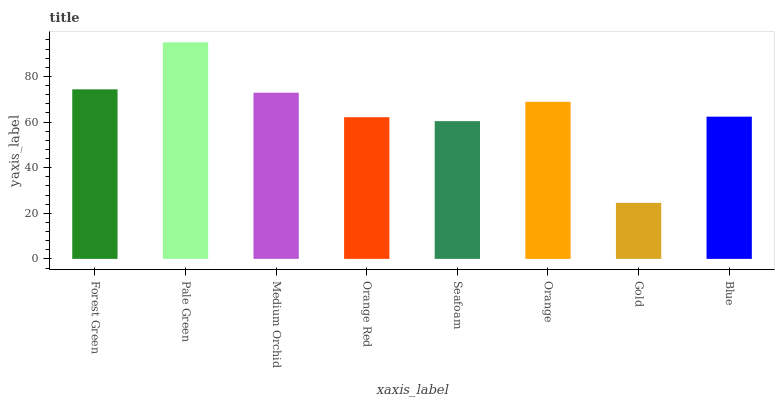Is Gold the minimum?
Answer yes or no. Yes. Is Pale Green the maximum?
Answer yes or no. Yes. Is Medium Orchid the minimum?
Answer yes or no. No. Is Medium Orchid the maximum?
Answer yes or no. No. Is Pale Green greater than Medium Orchid?
Answer yes or no. Yes. Is Medium Orchid less than Pale Green?
Answer yes or no. Yes. Is Medium Orchid greater than Pale Green?
Answer yes or no. No. Is Pale Green less than Medium Orchid?
Answer yes or no. No. Is Orange the high median?
Answer yes or no. Yes. Is Blue the low median?
Answer yes or no. Yes. Is Orange Red the high median?
Answer yes or no. No. Is Orange the low median?
Answer yes or no. No. 